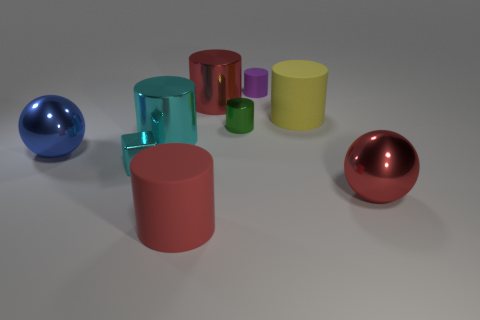Subtract all yellow cylinders. How many cylinders are left? 5 Subtract all big yellow matte cylinders. How many cylinders are left? 5 Subtract all gray cylinders. Subtract all brown balls. How many cylinders are left? 6 Add 1 small cyan objects. How many objects exist? 10 Subtract all balls. How many objects are left? 7 Subtract all large cylinders. Subtract all small purple objects. How many objects are left? 4 Add 5 metal balls. How many metal balls are left? 7 Add 7 small cyan metallic blocks. How many small cyan metallic blocks exist? 8 Subtract 0 brown balls. How many objects are left? 9 